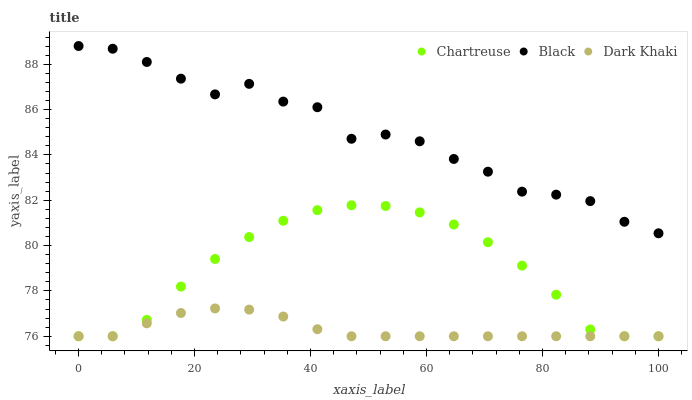Does Dark Khaki have the minimum area under the curve?
Answer yes or no. Yes. Does Black have the maximum area under the curve?
Answer yes or no. Yes. Does Chartreuse have the minimum area under the curve?
Answer yes or no. No. Does Chartreuse have the maximum area under the curve?
Answer yes or no. No. Is Dark Khaki the smoothest?
Answer yes or no. Yes. Is Black the roughest?
Answer yes or no. Yes. Is Chartreuse the smoothest?
Answer yes or no. No. Is Chartreuse the roughest?
Answer yes or no. No. Does Dark Khaki have the lowest value?
Answer yes or no. Yes. Does Black have the lowest value?
Answer yes or no. No. Does Black have the highest value?
Answer yes or no. Yes. Does Chartreuse have the highest value?
Answer yes or no. No. Is Chartreuse less than Black?
Answer yes or no. Yes. Is Black greater than Dark Khaki?
Answer yes or no. Yes. Does Chartreuse intersect Dark Khaki?
Answer yes or no. Yes. Is Chartreuse less than Dark Khaki?
Answer yes or no. No. Is Chartreuse greater than Dark Khaki?
Answer yes or no. No. Does Chartreuse intersect Black?
Answer yes or no. No. 